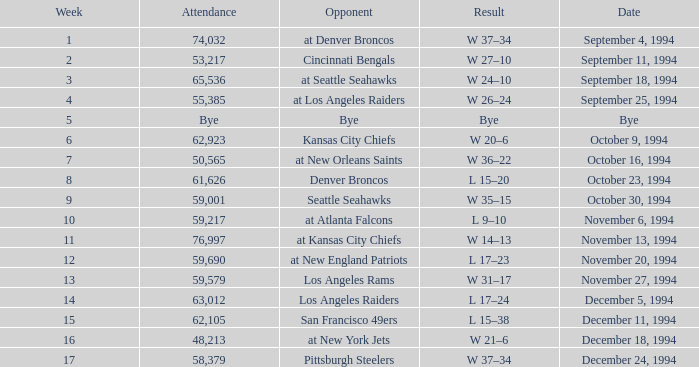In the game where they played the Pittsburgh Steelers, what was the attendance? 58379.0. 